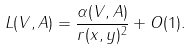<formula> <loc_0><loc_0><loc_500><loc_500>L ( V , A ) = \frac { \alpha ( V , A ) } { r ( x , y ) ^ { 2 } } + O ( 1 ) .</formula> 